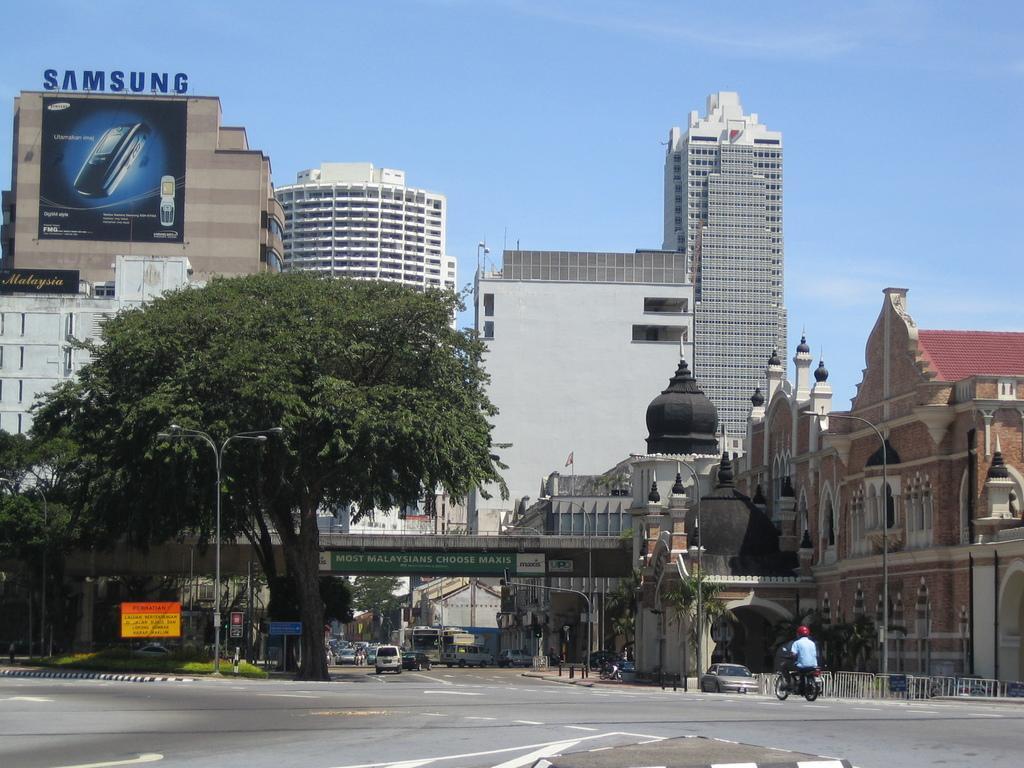In one or two sentences, can you explain what this image depicts? In this image there is a road in the middle. On the road there are vehicles. In the background there are tall buildings one beside the other. On the left side there is a hoarding on the building. There is a big tree on the footpath. In the middle there is a bridge. On the footpath there is grass and a board on it. 